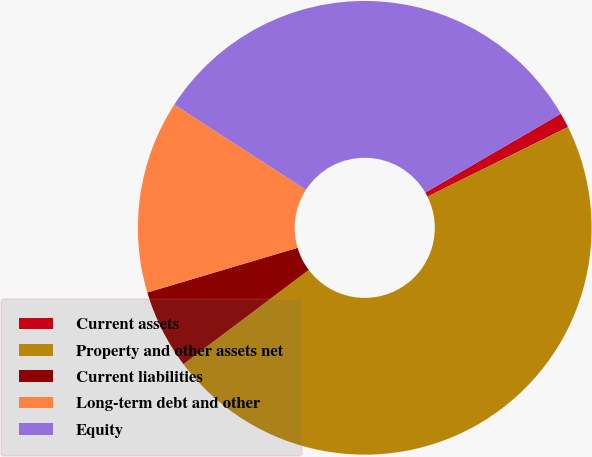<chart> <loc_0><loc_0><loc_500><loc_500><pie_chart><fcel>Current assets<fcel>Property and other assets net<fcel>Current liabilities<fcel>Long-term debt and other<fcel>Equity<nl><fcel>1.06%<fcel>47.07%<fcel>5.66%<fcel>13.74%<fcel>32.48%<nl></chart> 